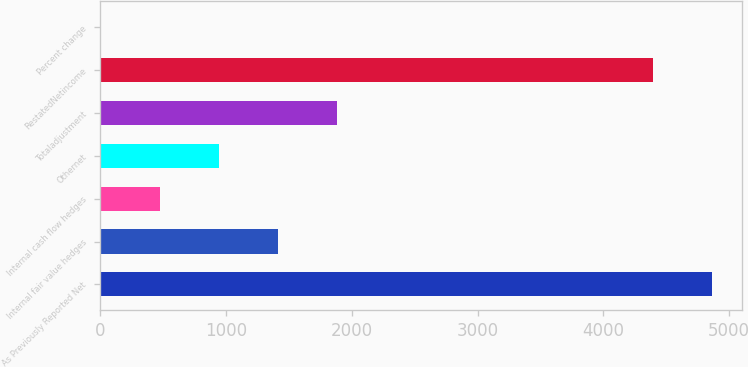<chart> <loc_0><loc_0><loc_500><loc_500><bar_chart><fcel>As Previously Reported Net<fcel>Internal fair value hedges<fcel>Internal cash flow hedges<fcel>Othernet<fcel>Totaladjustment<fcel>RestatedNetincome<fcel>Percent change<nl><fcel>4861.86<fcel>1412.98<fcel>475.26<fcel>944.12<fcel>1881.84<fcel>4393<fcel>6.4<nl></chart> 